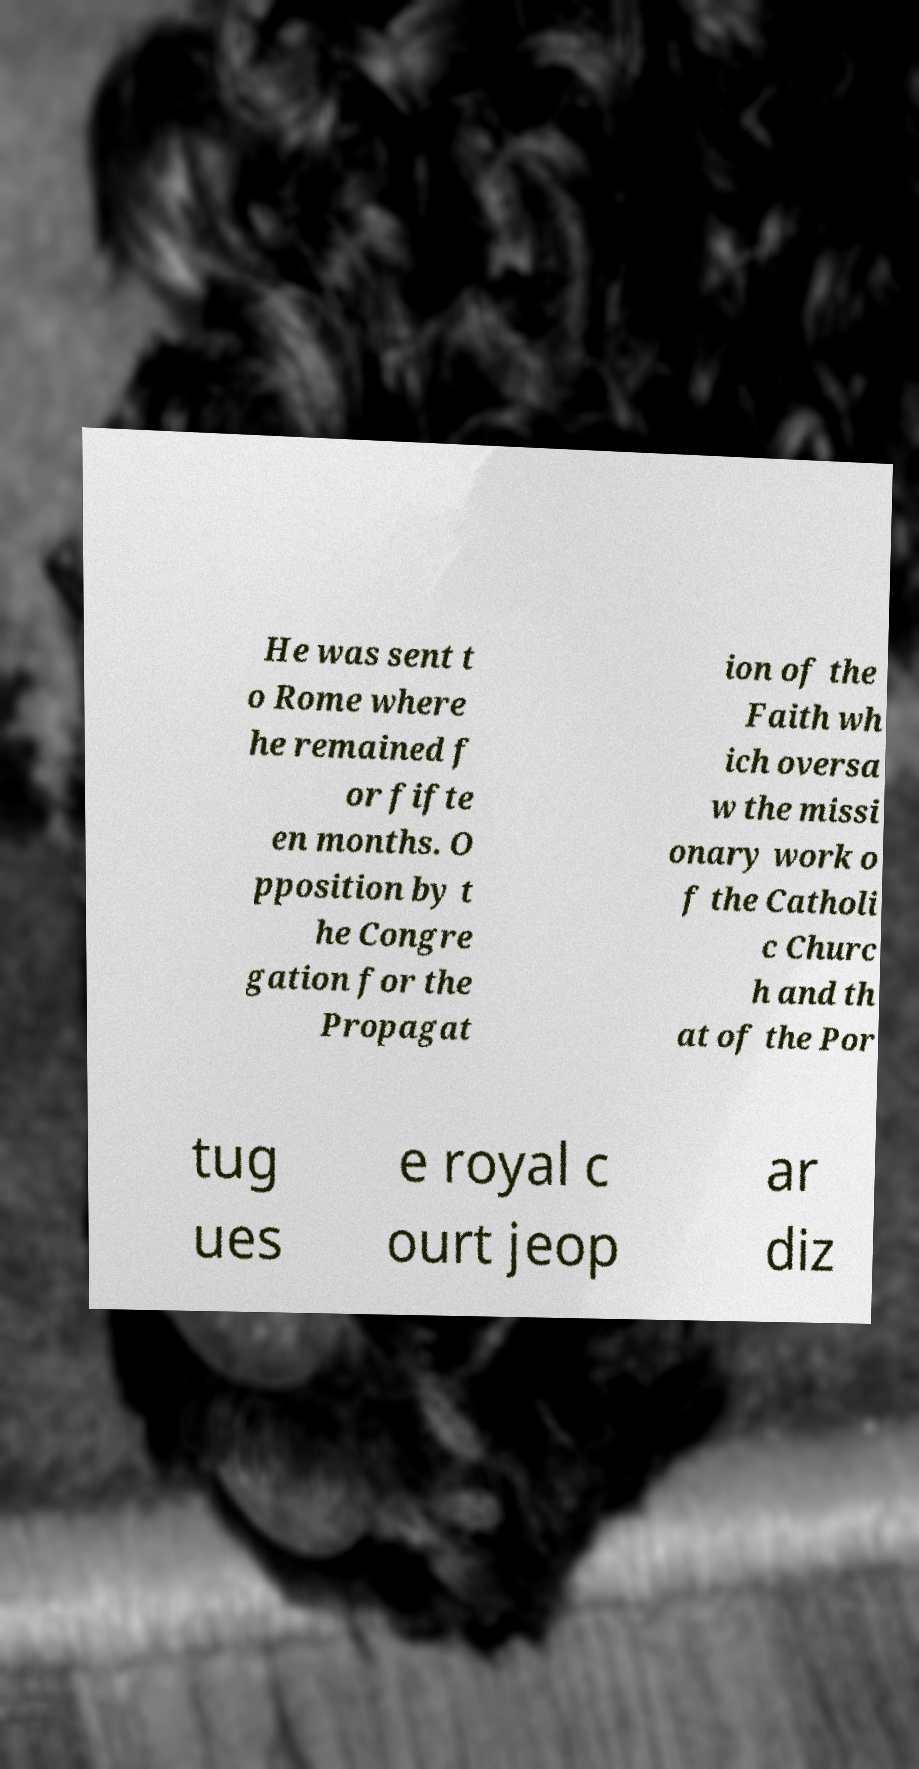Could you assist in decoding the text presented in this image and type it out clearly? He was sent t o Rome where he remained f or fifte en months. O pposition by t he Congre gation for the Propagat ion of the Faith wh ich oversa w the missi onary work o f the Catholi c Churc h and th at of the Por tug ues e royal c ourt jeop ar diz 